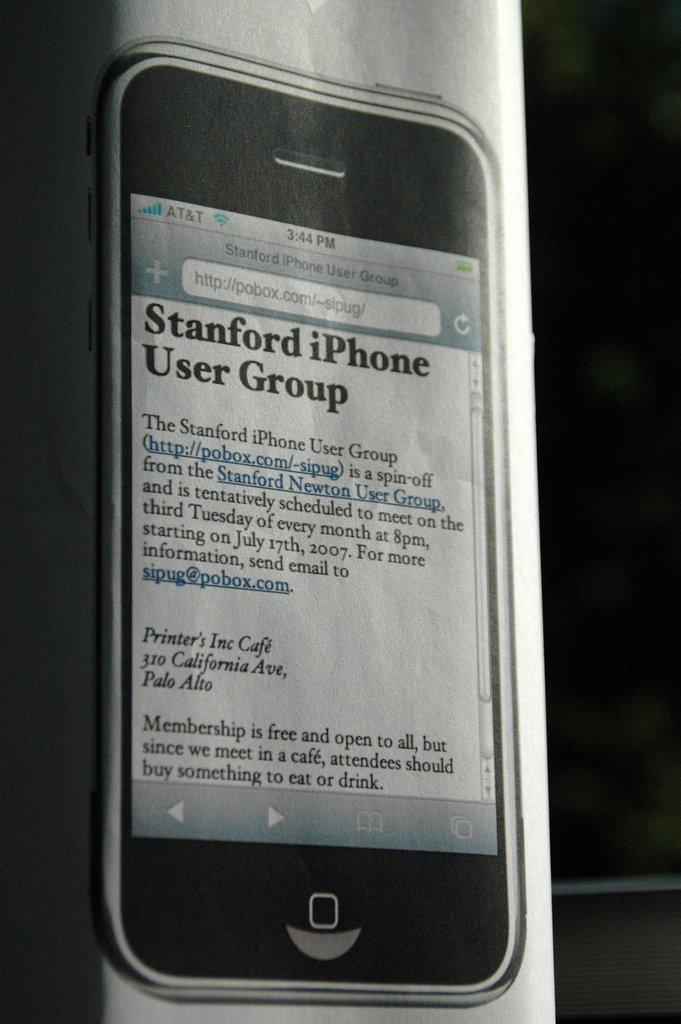<image>
Summarize the visual content of the image. A black iPhone is displaying the website for the Stanford iPhone User Group. 